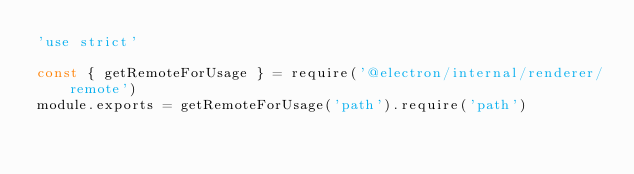Convert code to text. <code><loc_0><loc_0><loc_500><loc_500><_JavaScript_>'use strict'

const { getRemoteForUsage } = require('@electron/internal/renderer/remote')
module.exports = getRemoteForUsage('path').require('path')
</code> 